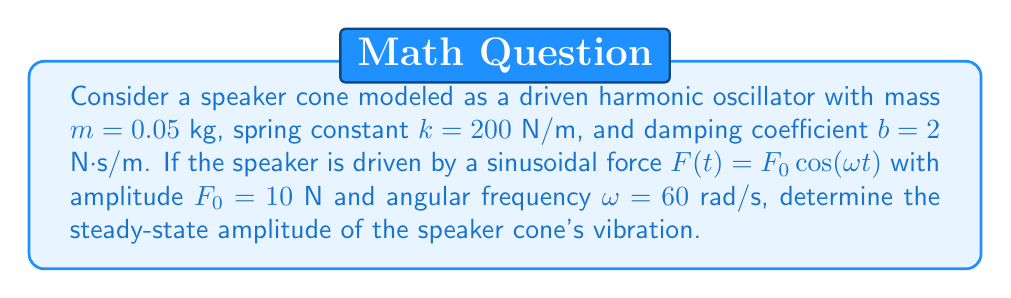Show me your answer to this math problem. To solve this problem, we'll follow these steps:

1) The equation of motion for a driven harmonic oscillator is:

   $$m\ddot{x} + b\dot{x} + kx = F_0 \cos(\omega t)$$

2) The steady-state solution has the form:

   $$x(t) = A \cos(\omega t - \phi)$$

   where $A$ is the amplitude we need to find.

3) The amplitude $A$ is given by:

   $$A = \frac{F_0}{\sqrt{(k-m\omega^2)^2 + (b\omega)^2}}$$

4) Let's substitute the given values:

   $m = 0.05$ kg
   $k = 200$ N/m
   $b = 2$ N⋅s/m
   $F_0 = 10$ N
   $\omega = 60$ rad/s

5) Calculate $(k-m\omega^2)^2$:
   $$(200 - 0.05 \cdot 60^2)^2 = (200 - 180)^2 = 20^2 = 400$$

6) Calculate $(b\omega)^2$:
   $$(2 \cdot 60)^2 = 120^2 = 14400$$

7) Sum these values:
   $$400 + 14400 = 14800$$

8) Take the square root:
   $$\sqrt{14800} \approx 121.655$$

9) Finally, divide $F_0$ by this value:
   $$A = \frac{10}{121.655} \approx 0.0822 \text{ m}$$

This amplitude represents the maximum displacement of the speaker cone from its equilibrium position in steady-state vibration.
Answer: 0.0822 m 